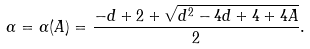<formula> <loc_0><loc_0><loc_500><loc_500>\alpha = \alpha ( A ) = \frac { - d + 2 + \sqrt { d ^ { 2 } - 4 d + 4 + 4 A } } { 2 } .</formula> 